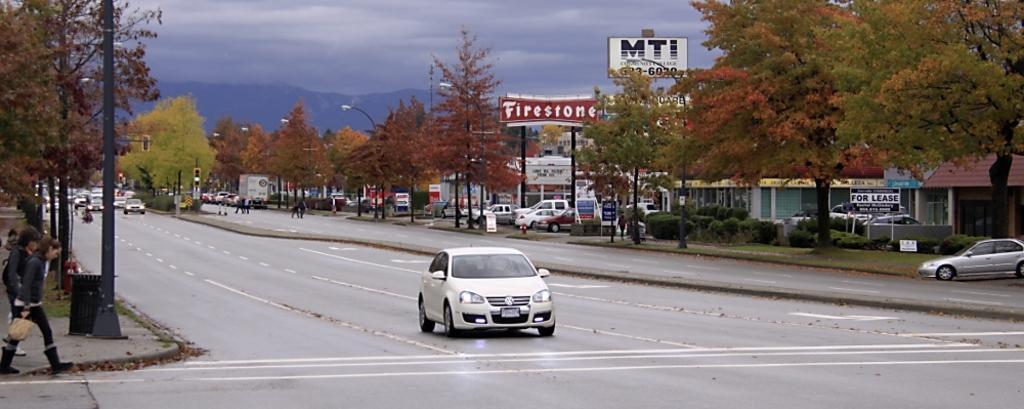How would you summarize this image in a sentence or two? In this image we can see some cars on the road. We can also see some poles, a group of people, a group of trees, plants, the sign boards with some text on them, street poles, some vehicles placed on the ground, some buildings, the hills and the sky which looks cloudy. 